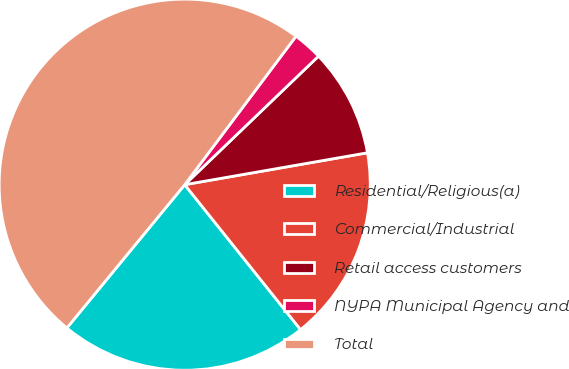Convert chart to OTSL. <chart><loc_0><loc_0><loc_500><loc_500><pie_chart><fcel>Residential/Religious(a)<fcel>Commercial/Industrial<fcel>Retail access customers<fcel>NYPA Municipal Agency and<fcel>Total<nl><fcel>21.69%<fcel>17.02%<fcel>9.43%<fcel>2.58%<fcel>49.29%<nl></chart> 